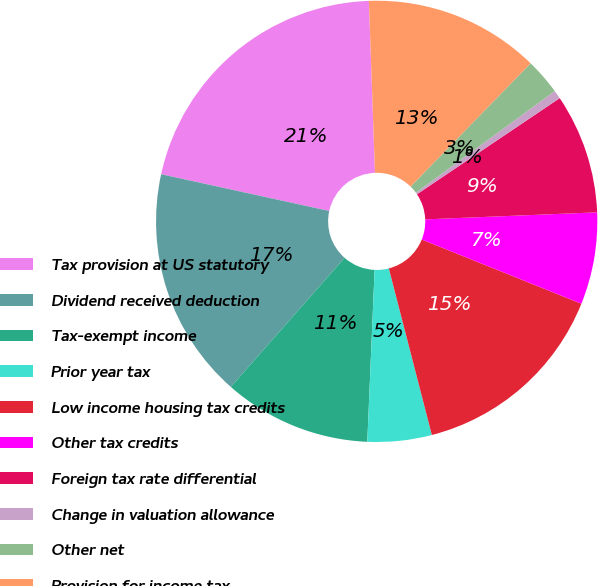<chart> <loc_0><loc_0><loc_500><loc_500><pie_chart><fcel>Tax provision at US statutory<fcel>Dividend received deduction<fcel>Tax-exempt income<fcel>Prior year tax<fcel>Low income housing tax credits<fcel>Other tax credits<fcel>Foreign tax rate differential<fcel>Change in valuation allowance<fcel>Other net<fcel>Provision for income tax<nl><fcel>21.01%<fcel>16.93%<fcel>10.82%<fcel>4.7%<fcel>14.89%<fcel>6.74%<fcel>8.78%<fcel>0.62%<fcel>2.66%<fcel>12.85%<nl></chart> 